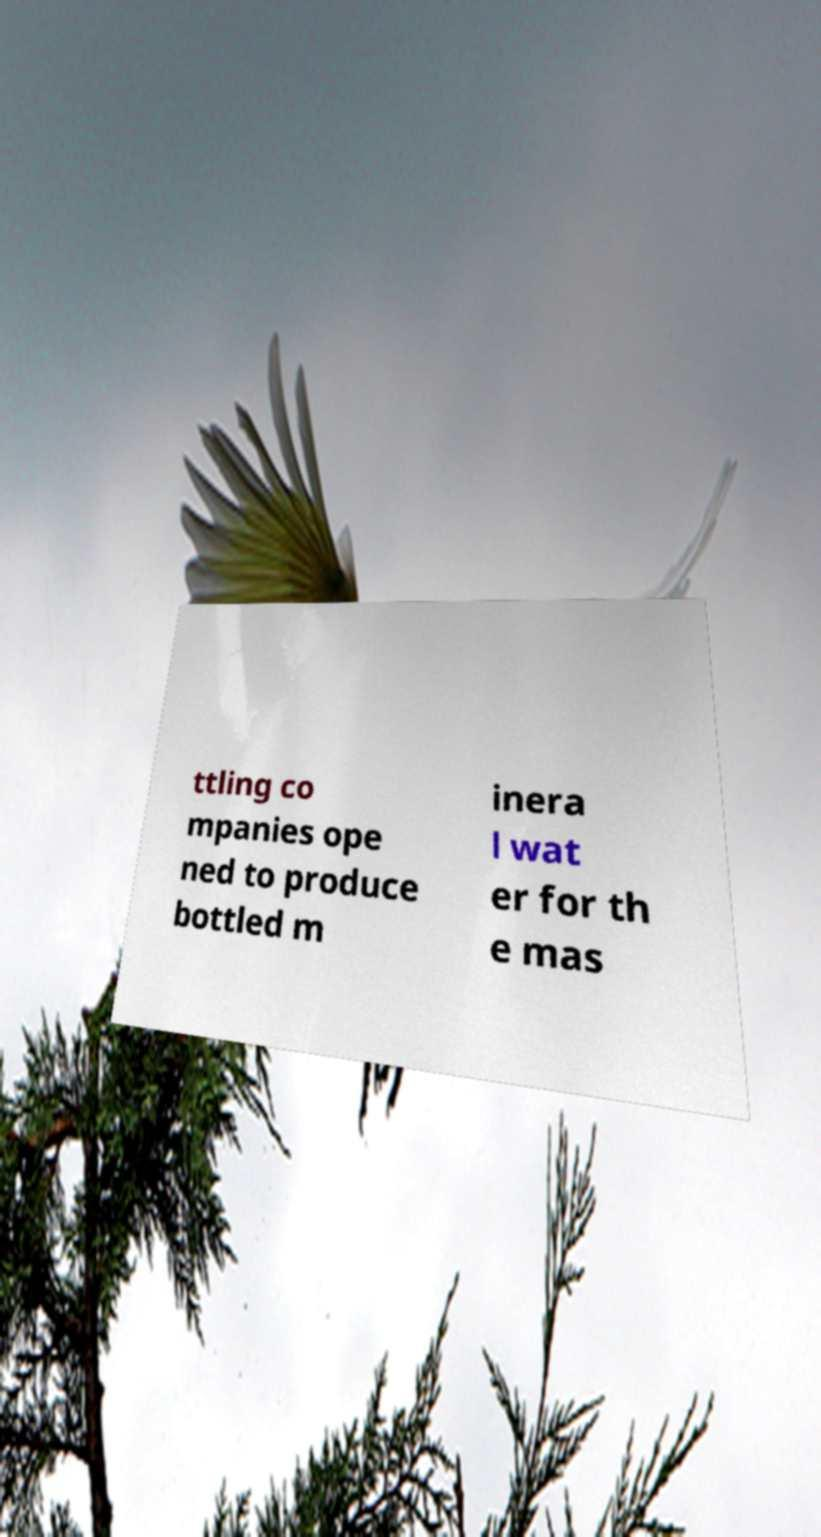Can you read and provide the text displayed in the image?This photo seems to have some interesting text. Can you extract and type it out for me? ttling co mpanies ope ned to produce bottled m inera l wat er for th e mas 